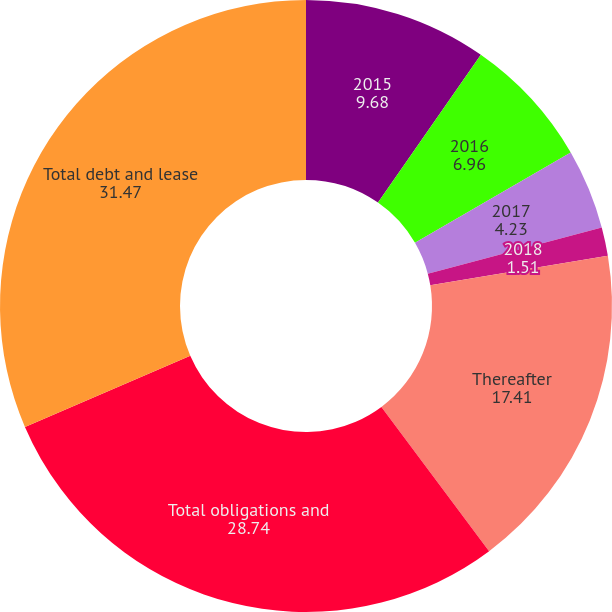<chart> <loc_0><loc_0><loc_500><loc_500><pie_chart><fcel>2015<fcel>2016<fcel>2017<fcel>2018<fcel>Thereafter<fcel>Total obligations and<fcel>Total debt and lease<nl><fcel>9.68%<fcel>6.96%<fcel>4.23%<fcel>1.51%<fcel>17.41%<fcel>28.74%<fcel>31.47%<nl></chart> 